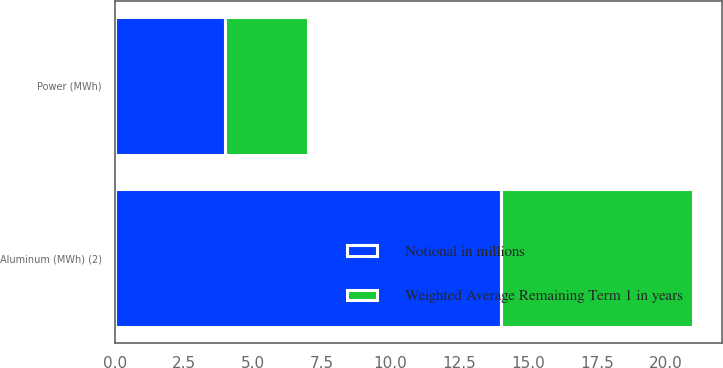Convert chart to OTSL. <chart><loc_0><loc_0><loc_500><loc_500><stacked_bar_chart><ecel><fcel>Aluminum (MWh) (2)<fcel>Power (MWh)<nl><fcel>Notional in millions<fcel>14<fcel>4<nl><fcel>Weighted Average Remaining Term 1 in years<fcel>7<fcel>3<nl></chart> 